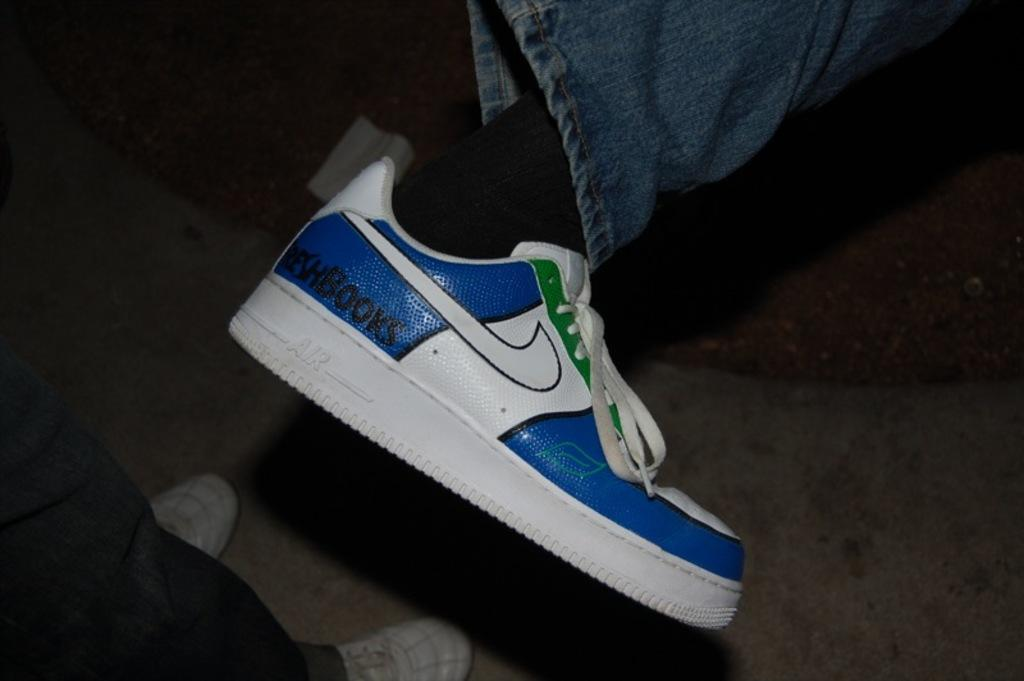How many people can be identified in the image based on their legs? There are legs of two persons in the image. What type of clothing is worn by one of the persons? One person is wearing jeans. What type of footwear is visible in the image? One person is wearing shoes. What can be said about the background of the image? The background of the image is dark. What type of sock is visible on the person's foot in the image? There is no sock visible in the image; only shoes are present. Can you tell me how many keys are being held by the person in the image? There is no person holding keys in the image. What type of vein is visible on the person's leg in the image? There is no visible vein on the person's leg in the image. 